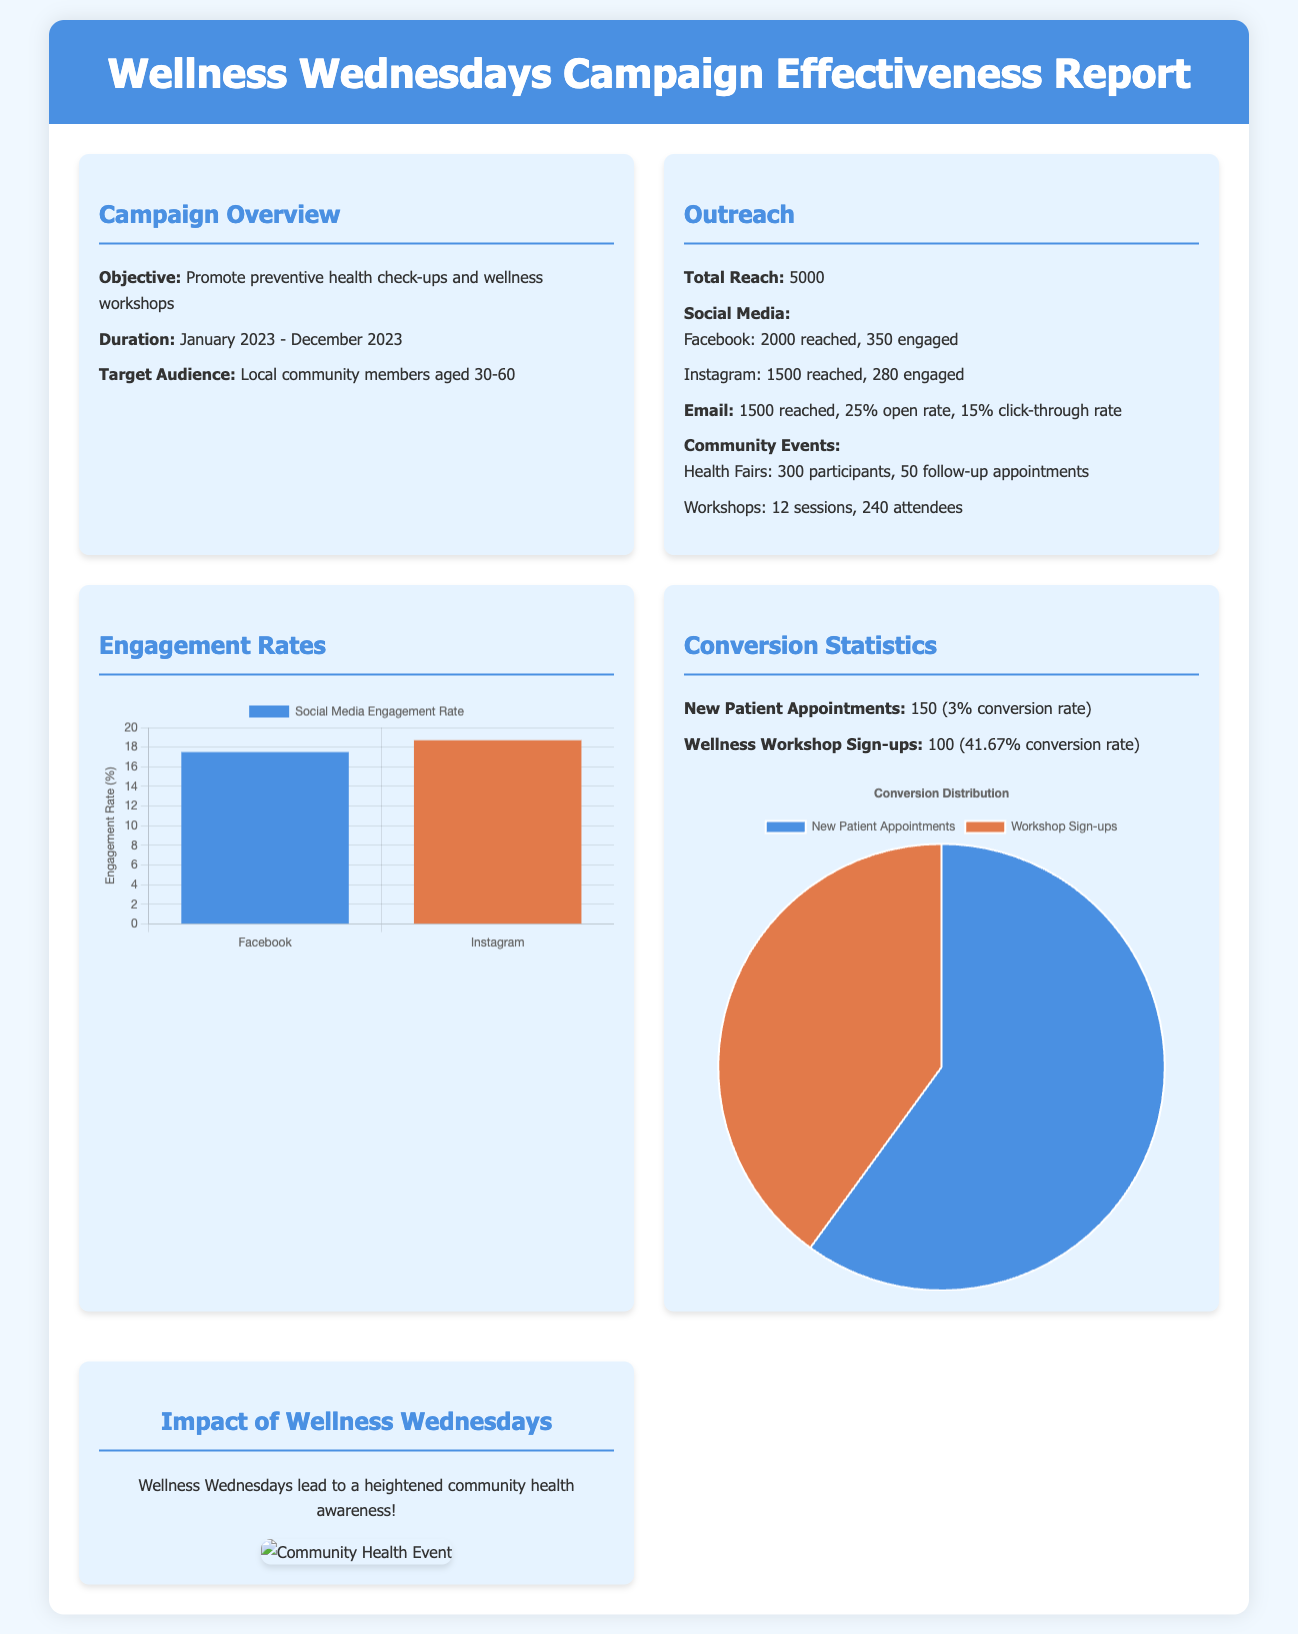What is the objective of the campaign? The objective is to promote preventive health check-ups and wellness workshops.
Answer: Promote preventive health check-ups and wellness workshops What is the total reach of the campaign? The total reach is the sum of all outreach channels mentioned in the document, which is 5000.
Answer: 5000 What percentage of emails had an open rate? The email open rate is specified as 25%.
Answer: 25% How many new patient appointments were made? The document states there were 150 new patient appointments.
Answer: 150 Which social media platform had a higher engagement rate? By comparing the engagement rates, Facebook had 17.5% and Instagram had 18.7%, making Instagram the higher one.
Answer: Instagram What is the conversion rate for wellness workshop sign-ups? The document specifies a conversion rate of 41.67% for wellness workshop sign-ups.
Answer: 41.67% How many community workshops were held? The document states that there were 12 workshop sessions held.
Answer: 12 What was the highlight impact of the Wellness Wednesdays? The highlight impact mentioned in the document is increased community health awareness.
Answer: Increased community health awareness 